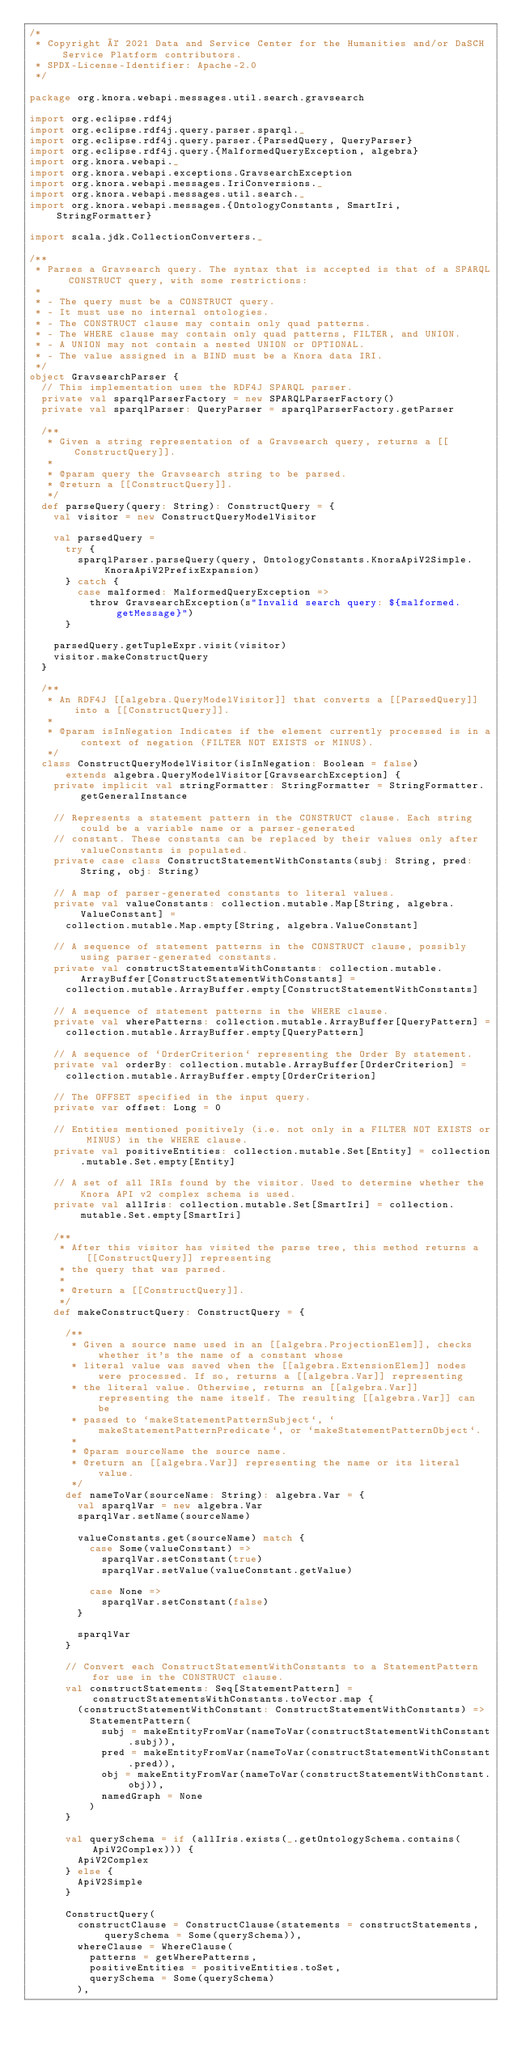Convert code to text. <code><loc_0><loc_0><loc_500><loc_500><_Scala_>/*
 * Copyright © 2021 Data and Service Center for the Humanities and/or DaSCH Service Platform contributors.
 * SPDX-License-Identifier: Apache-2.0
 */

package org.knora.webapi.messages.util.search.gravsearch

import org.eclipse.rdf4j
import org.eclipse.rdf4j.query.parser.sparql._
import org.eclipse.rdf4j.query.parser.{ParsedQuery, QueryParser}
import org.eclipse.rdf4j.query.{MalformedQueryException, algebra}
import org.knora.webapi._
import org.knora.webapi.exceptions.GravsearchException
import org.knora.webapi.messages.IriConversions._
import org.knora.webapi.messages.util.search._
import org.knora.webapi.messages.{OntologyConstants, SmartIri, StringFormatter}

import scala.jdk.CollectionConverters._

/**
 * Parses a Gravsearch query. The syntax that is accepted is that of a SPARQL CONSTRUCT query, with some restrictions:
 *
 * - The query must be a CONSTRUCT query.
 * - It must use no internal ontologies.
 * - The CONSTRUCT clause may contain only quad patterns.
 * - The WHERE clause may contain only quad patterns, FILTER, and UNION.
 * - A UNION may not contain a nested UNION or OPTIONAL.
 * - The value assigned in a BIND must be a Knora data IRI.
 */
object GravsearchParser {
  // This implementation uses the RDF4J SPARQL parser.
  private val sparqlParserFactory = new SPARQLParserFactory()
  private val sparqlParser: QueryParser = sparqlParserFactory.getParser

  /**
   * Given a string representation of a Gravsearch query, returns a [[ConstructQuery]].
   *
   * @param query the Gravsearch string to be parsed.
   * @return a [[ConstructQuery]].
   */
  def parseQuery(query: String): ConstructQuery = {
    val visitor = new ConstructQueryModelVisitor

    val parsedQuery =
      try {
        sparqlParser.parseQuery(query, OntologyConstants.KnoraApiV2Simple.KnoraApiV2PrefixExpansion)
      } catch {
        case malformed: MalformedQueryException =>
          throw GravsearchException(s"Invalid search query: ${malformed.getMessage}")
      }

    parsedQuery.getTupleExpr.visit(visitor)
    visitor.makeConstructQuery
  }

  /**
   * An RDF4J [[algebra.QueryModelVisitor]] that converts a [[ParsedQuery]] into a [[ConstructQuery]].
   *
   * @param isInNegation Indicates if the element currently processed is in a context of negation (FILTER NOT EXISTS or MINUS).
   */
  class ConstructQueryModelVisitor(isInNegation: Boolean = false)
      extends algebra.QueryModelVisitor[GravsearchException] {
    private implicit val stringFormatter: StringFormatter = StringFormatter.getGeneralInstance

    // Represents a statement pattern in the CONSTRUCT clause. Each string could be a variable name or a parser-generated
    // constant. These constants can be replaced by their values only after valueConstants is populated.
    private case class ConstructStatementWithConstants(subj: String, pred: String, obj: String)

    // A map of parser-generated constants to literal values.
    private val valueConstants: collection.mutable.Map[String, algebra.ValueConstant] =
      collection.mutable.Map.empty[String, algebra.ValueConstant]

    // A sequence of statement patterns in the CONSTRUCT clause, possibly using parser-generated constants.
    private val constructStatementsWithConstants: collection.mutable.ArrayBuffer[ConstructStatementWithConstants] =
      collection.mutable.ArrayBuffer.empty[ConstructStatementWithConstants]

    // A sequence of statement patterns in the WHERE clause.
    private val wherePatterns: collection.mutable.ArrayBuffer[QueryPattern] =
      collection.mutable.ArrayBuffer.empty[QueryPattern]

    // A sequence of `OrderCriterion` representing the Order By statement.
    private val orderBy: collection.mutable.ArrayBuffer[OrderCriterion] =
      collection.mutable.ArrayBuffer.empty[OrderCriterion]

    // The OFFSET specified in the input query.
    private var offset: Long = 0

    // Entities mentioned positively (i.e. not only in a FILTER NOT EXISTS or MINUS) in the WHERE clause.
    private val positiveEntities: collection.mutable.Set[Entity] = collection.mutable.Set.empty[Entity]

    // A set of all IRIs found by the visitor. Used to determine whether the Knora API v2 complex schema is used.
    private val allIris: collection.mutable.Set[SmartIri] = collection.mutable.Set.empty[SmartIri]

    /**
     * After this visitor has visited the parse tree, this method returns a [[ConstructQuery]] representing
     * the query that was parsed.
     *
     * @return a [[ConstructQuery]].
     */
    def makeConstructQuery: ConstructQuery = {

      /**
       * Given a source name used in an [[algebra.ProjectionElem]], checks whether it's the name of a constant whose
       * literal value was saved when the [[algebra.ExtensionElem]] nodes were processed. If so, returns a [[algebra.Var]] representing
       * the literal value. Otherwise, returns an [[algebra.Var]] representing the name itself. The resulting [[algebra.Var]] can be
       * passed to `makeStatementPatternSubject`, `makeStatementPatternPredicate`, or `makeStatementPatternObject`.
       *
       * @param sourceName the source name.
       * @return an [[algebra.Var]] representing the name or its literal value.
       */
      def nameToVar(sourceName: String): algebra.Var = {
        val sparqlVar = new algebra.Var
        sparqlVar.setName(sourceName)

        valueConstants.get(sourceName) match {
          case Some(valueConstant) =>
            sparqlVar.setConstant(true)
            sparqlVar.setValue(valueConstant.getValue)

          case None =>
            sparqlVar.setConstant(false)
        }

        sparqlVar
      }

      // Convert each ConstructStatementWithConstants to a StatementPattern for use in the CONSTRUCT clause.
      val constructStatements: Seq[StatementPattern] = constructStatementsWithConstants.toVector.map {
        (constructStatementWithConstant: ConstructStatementWithConstants) =>
          StatementPattern(
            subj = makeEntityFromVar(nameToVar(constructStatementWithConstant.subj)),
            pred = makeEntityFromVar(nameToVar(constructStatementWithConstant.pred)),
            obj = makeEntityFromVar(nameToVar(constructStatementWithConstant.obj)),
            namedGraph = None
          )
      }

      val querySchema = if (allIris.exists(_.getOntologySchema.contains(ApiV2Complex))) {
        ApiV2Complex
      } else {
        ApiV2Simple
      }

      ConstructQuery(
        constructClause = ConstructClause(statements = constructStatements, querySchema = Some(querySchema)),
        whereClause = WhereClause(
          patterns = getWherePatterns,
          positiveEntities = positiveEntities.toSet,
          querySchema = Some(querySchema)
        ),</code> 